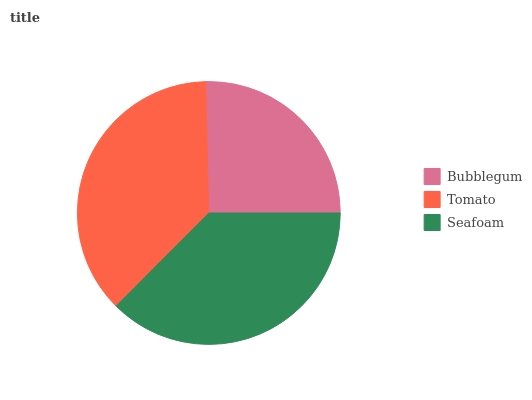Is Bubblegum the minimum?
Answer yes or no. Yes. Is Seafoam the maximum?
Answer yes or no. Yes. Is Tomato the minimum?
Answer yes or no. No. Is Tomato the maximum?
Answer yes or no. No. Is Tomato greater than Bubblegum?
Answer yes or no. Yes. Is Bubblegum less than Tomato?
Answer yes or no. Yes. Is Bubblegum greater than Tomato?
Answer yes or no. No. Is Tomato less than Bubblegum?
Answer yes or no. No. Is Tomato the high median?
Answer yes or no. Yes. Is Tomato the low median?
Answer yes or no. Yes. Is Seafoam the high median?
Answer yes or no. No. Is Seafoam the low median?
Answer yes or no. No. 